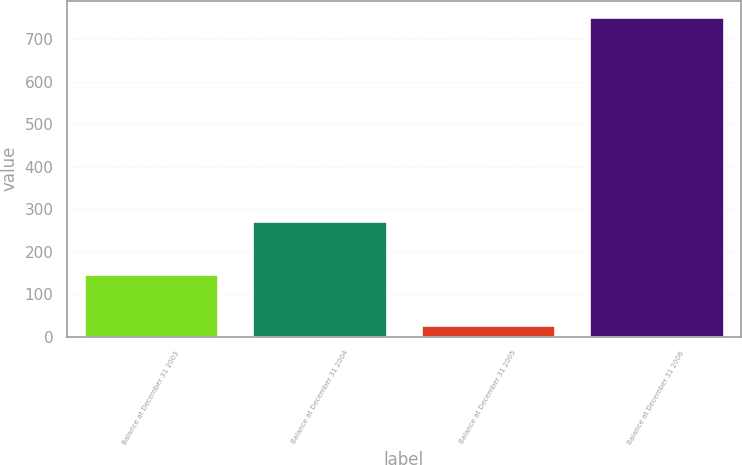Convert chart to OTSL. <chart><loc_0><loc_0><loc_500><loc_500><bar_chart><fcel>Balance at December 31 2003<fcel>Balance at December 31 2004<fcel>Balance at December 31 2005<fcel>Balance at December 31 2006<nl><fcel>147<fcel>273<fcel>27<fcel>753<nl></chart> 